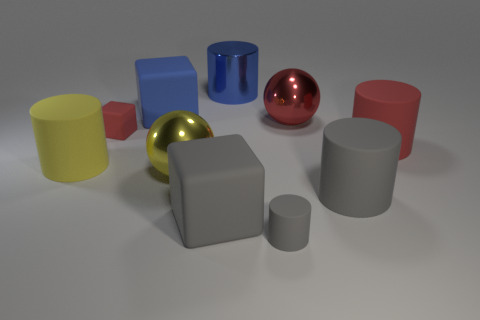Subtract all red cylinders. How many cylinders are left? 4 Subtract all small gray rubber cylinders. How many cylinders are left? 4 Subtract 2 cylinders. How many cylinders are left? 3 Subtract all cyan cylinders. Subtract all red cubes. How many cylinders are left? 5 Subtract all blocks. How many objects are left? 7 Subtract all tiny cubes. Subtract all tiny blocks. How many objects are left? 8 Add 3 yellow metallic spheres. How many yellow metallic spheres are left? 4 Add 2 big red matte spheres. How many big red matte spheres exist? 2 Subtract 0 cyan balls. How many objects are left? 10 